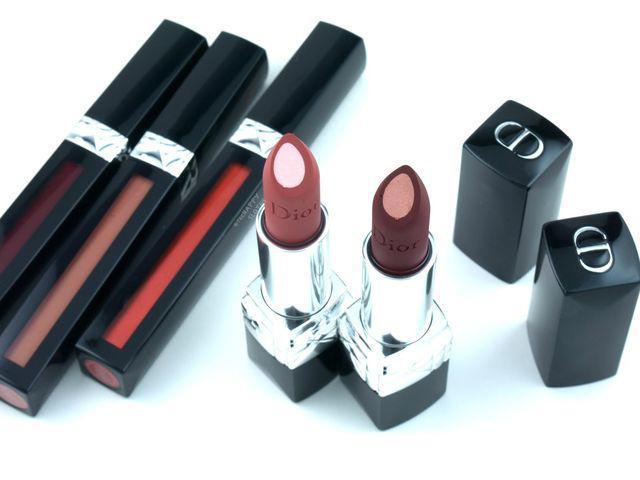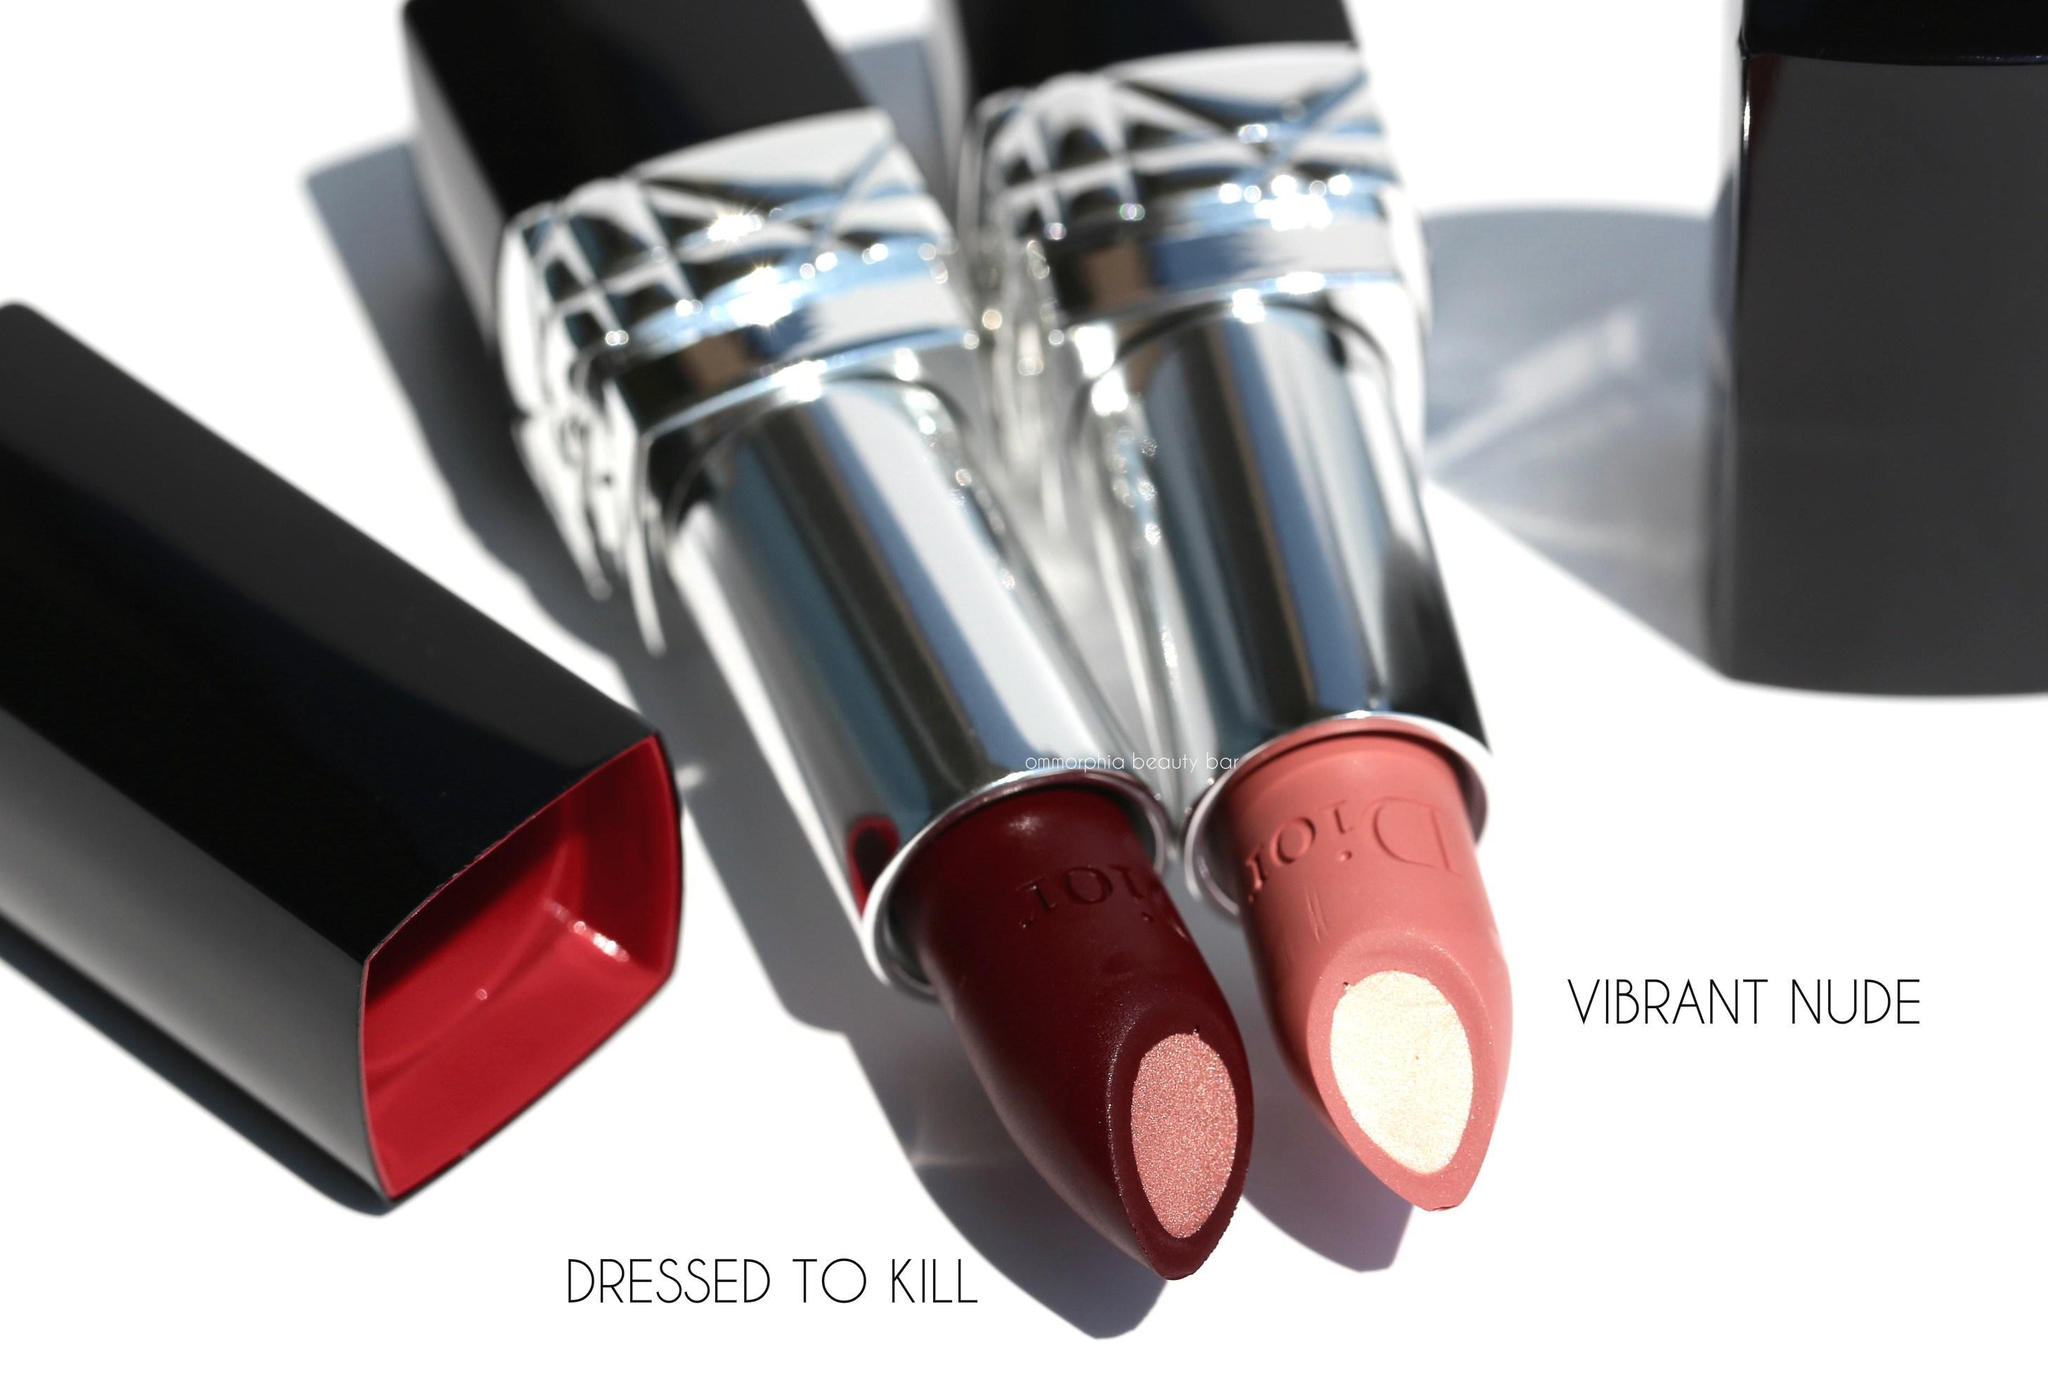The first image is the image on the left, the second image is the image on the right. Analyze the images presented: Is the assertion "At least one of the images is of Dior lipstick colors" valid? Answer yes or no. Yes. 